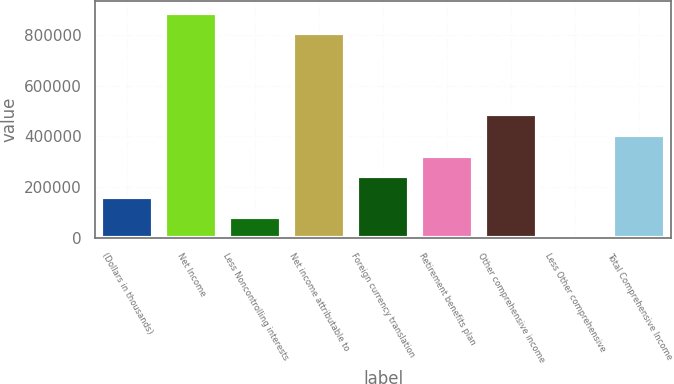Convert chart to OTSL. <chart><loc_0><loc_0><loc_500><loc_500><bar_chart><fcel>(Dollars in thousands)<fcel>Net Income<fcel>Less Noncontrolling interests<fcel>Net income attributable to<fcel>Foreign currency translation<fcel>Retirement benefits plan<fcel>Other comprehensive income<fcel>Less Other comprehensive<fcel>Total Comprehensive Income<nl><fcel>161600<fcel>887542<fcel>80898<fcel>806840<fcel>242302<fcel>323004<fcel>489147<fcel>196<fcel>403706<nl></chart> 